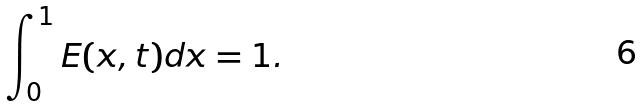<formula> <loc_0><loc_0><loc_500><loc_500>\int _ { 0 } ^ { 1 } E ( x , t ) d x = 1 .</formula> 